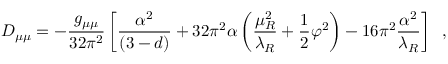<formula> <loc_0><loc_0><loc_500><loc_500>D _ { \mu \mu } = - \frac { g _ { \mu \mu } } { 3 2 \pi ^ { 2 } } \left [ \frac { \alpha ^ { 2 } } { ( 3 - d ) } + 3 2 \pi ^ { 2 } \alpha \left ( \frac { \mu _ { R } ^ { 2 } } { \lambda _ { R } } + \frac { 1 } { 2 } \varphi ^ { 2 } \right ) - 1 6 \pi ^ { 2 } \frac { \alpha ^ { 2 } } { \lambda _ { R } } \right ] \, ,</formula> 